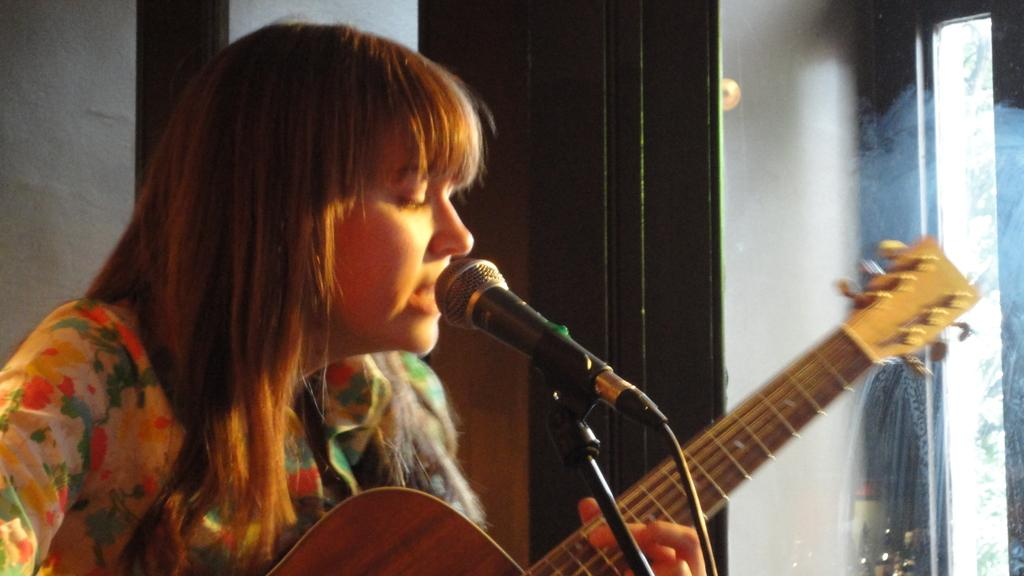Who is the main subject in the image? There is a woman in the image. What is the woman doing in the image? The woman is singing and playing a guitar. What equipment is visible in the image that is related to the woman's singing? There is a microphone and a microphone stand in the image. Where are the microphone and stand positioned in relation to the woman? The microphone and stand are in front of the woman. What can be seen on the right side of the image? There is a window on the right side of the image. What type of juice is being squeezed by the expert in the image? There is no expert or juice present in the image; it features a woman singing and playing a guitar. 